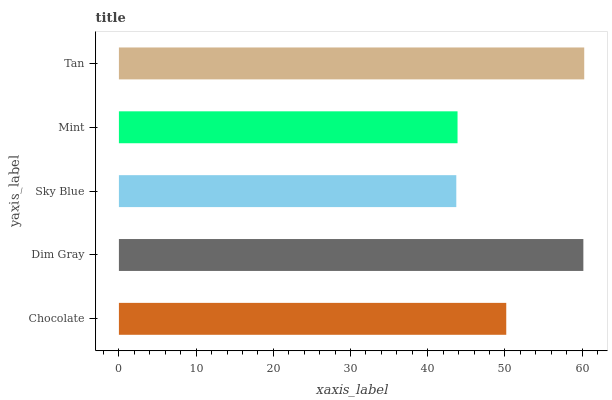Is Sky Blue the minimum?
Answer yes or no. Yes. Is Tan the maximum?
Answer yes or no. Yes. Is Dim Gray the minimum?
Answer yes or no. No. Is Dim Gray the maximum?
Answer yes or no. No. Is Dim Gray greater than Chocolate?
Answer yes or no. Yes. Is Chocolate less than Dim Gray?
Answer yes or no. Yes. Is Chocolate greater than Dim Gray?
Answer yes or no. No. Is Dim Gray less than Chocolate?
Answer yes or no. No. Is Chocolate the high median?
Answer yes or no. Yes. Is Chocolate the low median?
Answer yes or no. Yes. Is Dim Gray the high median?
Answer yes or no. No. Is Dim Gray the low median?
Answer yes or no. No. 